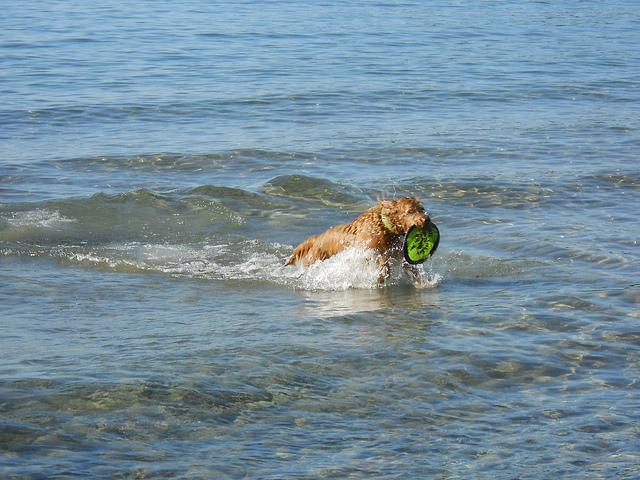What kind of animal is this?
Be succinct. Dog. What color is the frisbee?
Be succinct. Green. Is this a sporting dog?
Keep it brief. Yes. What is the dog playing with?
Concise answer only. Frisbee. Does the water appear muddy?
Keep it brief. No. What is in this animals mouth?
Give a very brief answer. Frisbee. 